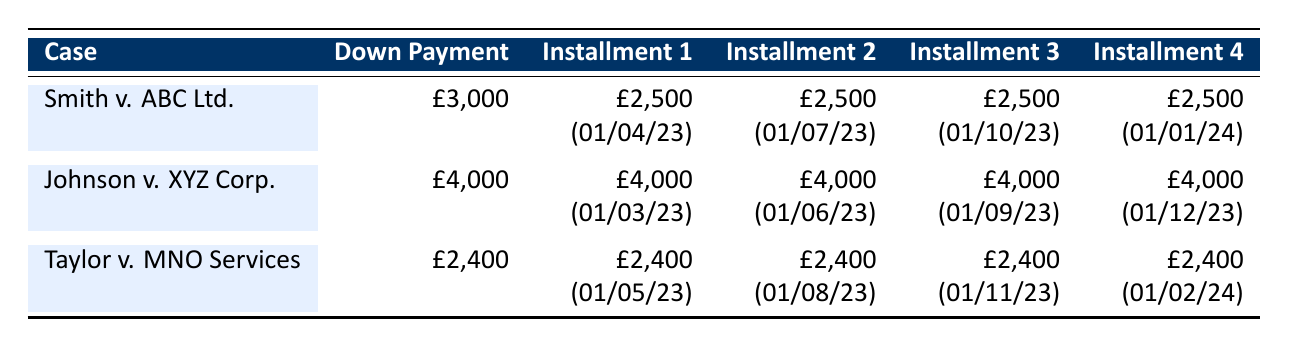What is the total amount of legal fees in the case of Smith v. ABC Ltd.? The total fees for Smith v. ABC Ltd. are listed directly in the table under "total_fees," which shows £15,000.
Answer: £15,000 What is the down payment for Johnson v. XYZ Corp.? The down payment for Johnson v. XYZ Corp. is explicitly stated in the table under "Down Payment," which is £4,000.
Answer: £4,000 Which case has the largest total legal fees? By comparing the total fees for each case, Smith v. ABC Ltd. has £15,000, Johnson v. XYZ Corp. has £20,000, and Taylor v. MNO Services has £12,000. Thus, Johnson v. XYZ Corp. has the largest total fees.
Answer: Johnson v. XYZ Corp Are the installment amounts for Taylor v. MNO Services equal? Looking at the table, each of the installments for Taylor v. MNO Services is noted as £2,400, confirming that they are indeed equal.
Answer: Yes What is the total of down payments and first installments across all cases? The down payments are £3,000 (Smith) + £4,000 (Johnson) + £2,400 (Taylor) = £9,400. The first installments are £2,500 (Smith) + £4,000 (Johnson) + £2,400 (Taylor) = £8,900. Summing these, we have £9,400 + £8,900 = £18,300 as the total.
Answer: £18,300 When is the last installment due for Smith v. ABC Ltd.? The data indicates that the last installment for Smith v. ABC Ltd. is due on 01/04/24, which is the date associated with the fourth installment.
Answer: 01/04/24 How many payments are scheduled for Taylor v. MNO Services? Taylor v. MNO Services has one down payment and four installments listed, making a total of five scheduled payments.
Answer: 5 Is the total amount of legal fees for any case exactly £12,000? By reviewing the amounts, total fees are £15,000 (Smith), £20,000 (Johnson), and £12,000 (Taylor), confirming one case does have this amount.
Answer: Yes What will be the total legal fees paid by Johnson v. XYZ Corp. by March 2024? The down payment is £4,000 and the first four installments of £4,000 each total to £16,000, leading to a cumulative total of £4,000 + £16,000 = £20,000 by March 2024.
Answer: £20,000 